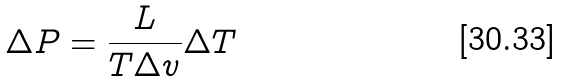Convert formula to latex. <formula><loc_0><loc_0><loc_500><loc_500>\Delta P = \frac { L } { T \Delta v } \Delta T</formula> 